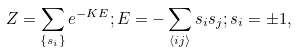Convert formula to latex. <formula><loc_0><loc_0><loc_500><loc_500>Z = \sum _ { \{ s _ { i } \} } e ^ { - K E } ; E = - \sum _ { \langle i j \rangle } s _ { i } s _ { j } ; s _ { i } = \pm 1 ,</formula> 